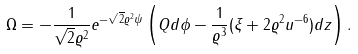Convert formula to latex. <formula><loc_0><loc_0><loc_500><loc_500>\Omega = - { \frac { 1 } { \sqrt { 2 } \varrho ^ { 2 } } } e ^ { - \sqrt { 2 } \varrho ^ { 2 } \psi } \left ( Q d \phi - { \frac { 1 } { \varrho ^ { 3 } } } ( \xi + 2 \varrho ^ { 2 } u ^ { - 6 } ) d z \right ) .</formula> 